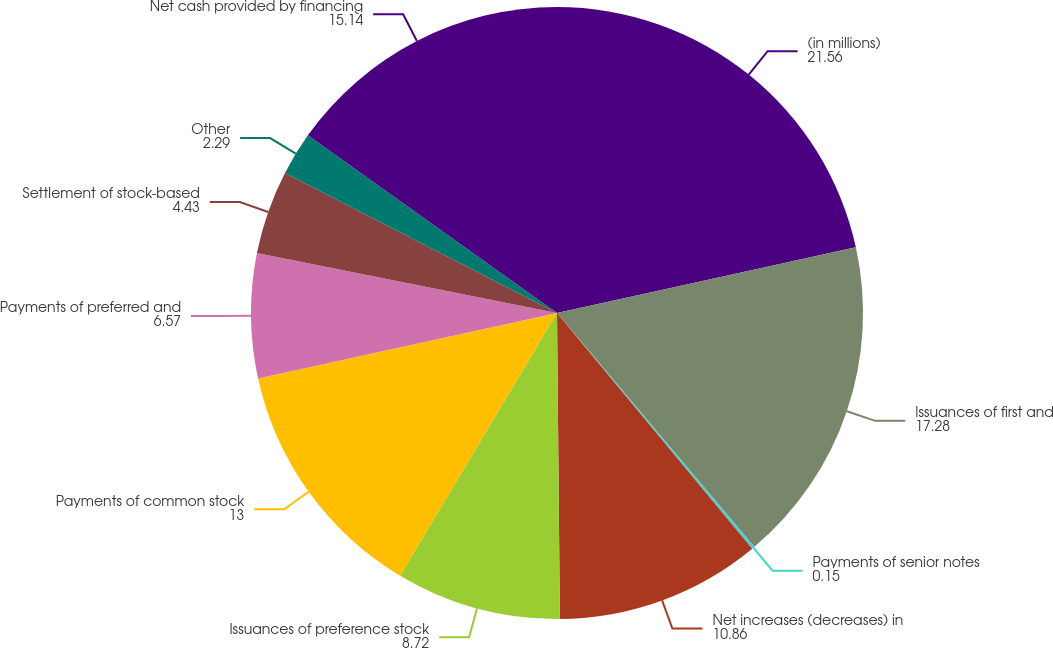Convert chart. <chart><loc_0><loc_0><loc_500><loc_500><pie_chart><fcel>(in millions)<fcel>Issuances of first and<fcel>Payments of senior notes<fcel>Net increases (decreases) in<fcel>Issuances of preference stock<fcel>Payments of common stock<fcel>Payments of preferred and<fcel>Settlement of stock-based<fcel>Other<fcel>Net cash provided by financing<nl><fcel>21.56%<fcel>17.28%<fcel>0.15%<fcel>10.86%<fcel>8.72%<fcel>13.0%<fcel>6.57%<fcel>4.43%<fcel>2.29%<fcel>15.14%<nl></chart> 